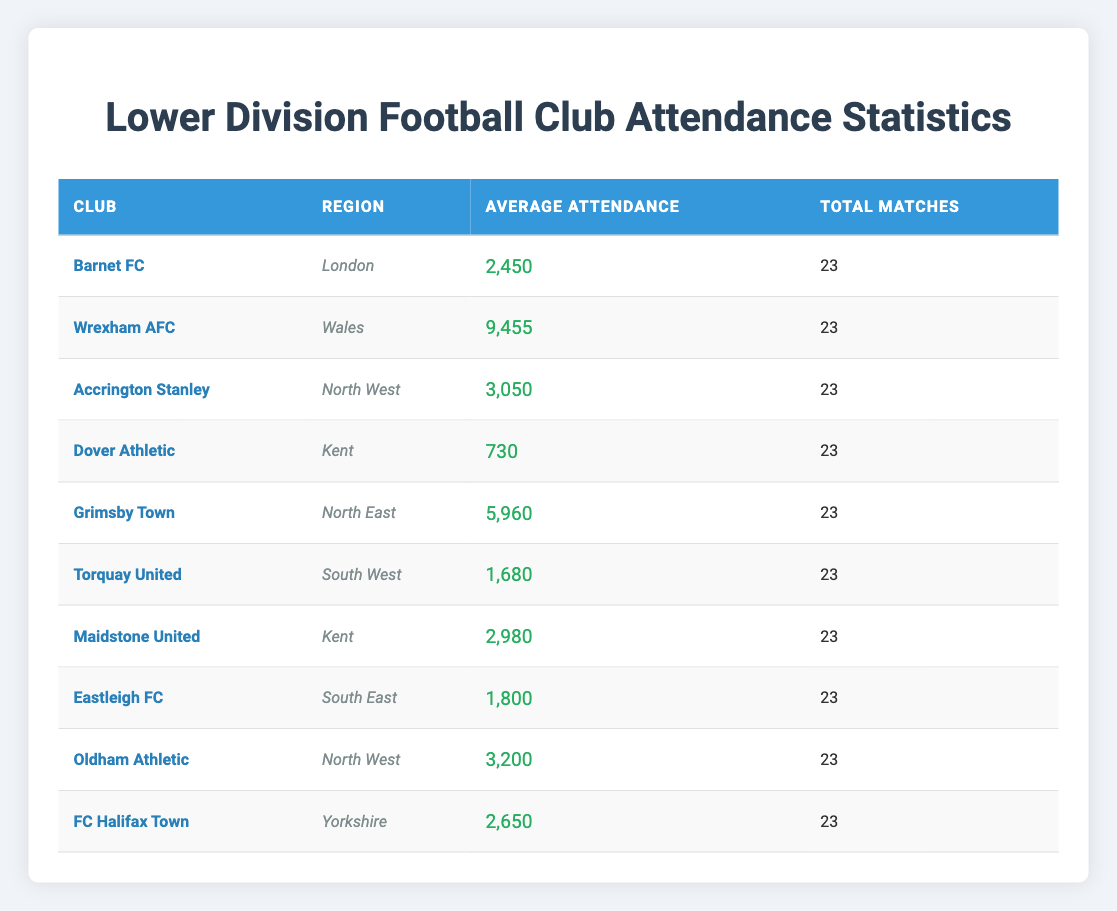What's the average attendance for Wrexham AFC? The average attendance for Wrexham AFC is listed directly in the table as 9,455.
Answer: 9,455 Which club has the highest average attendance? Looking at the average attendance figures in the table, Wrexham AFC has the highest figure at 9,455.
Answer: Wrexham AFC How many matches were played by Dover Athletic? The total matches played by Dover Athletic is provided in the table and is 23.
Answer: 23 What is the total average attendance for clubs from Kent? The average attendance for Dover Athletic is 730 and for Maidstone United is 2,980. Summing them gives 730 + 2980 = 3,710.
Answer: 3,710 Are there any clubs with an average attendance below 1,000? Dover Athletic has an average attendance of 730, which is below 1,000.
Answer: Yes Which region has the highest average attendance? To find this, we calculate the average attendance for each region: London (2,450), Wales (9,455), North West (3,050 average of Accrington Stanley and Oldham Athletic = (3,050 + 3,200)/2 = 3,125), Kent (3,710 from previous Q), North East (5,960), South West (1,680), South East (1,800), Yorkshire (2,650). The highest is in Wales with 9,455.
Answer: Wales How many clubs have an average attendance over 5,000? The clubs with an average attendance over 5,000 are Wrexham AFC (9,455) and Grimsby Town (5,960), giving us a total of 2 clubs.
Answer: 2 What is the average attendance of clubs in the North West region? The clubs in the North West are Accrington Stanley (3,050) and Oldham Athletic (3,200). The average is (3,050 + 3,200) / 2 = 3,125.
Answer: 3,125 Which club has the lowest average attendance? The lowest average attendance in the table is for Dover Athletic, which is 730.
Answer: Dover Athletic If we combined the average attendance for Maidstone United and Eastleigh FC, what would that total? Maidstone United has an average of 2,980 and Eastleigh FC has 1,800. Adding those gives 2,980 + 1,800 = 4,780.
Answer: 4,780 Is the average attendance for FC Halifax Town higher than that of Torquay United? FC Halifax Town has an average attendance of 2,650 while Torquay United has 1,680, so FC Halifax Town's attendance is higher.
Answer: Yes 